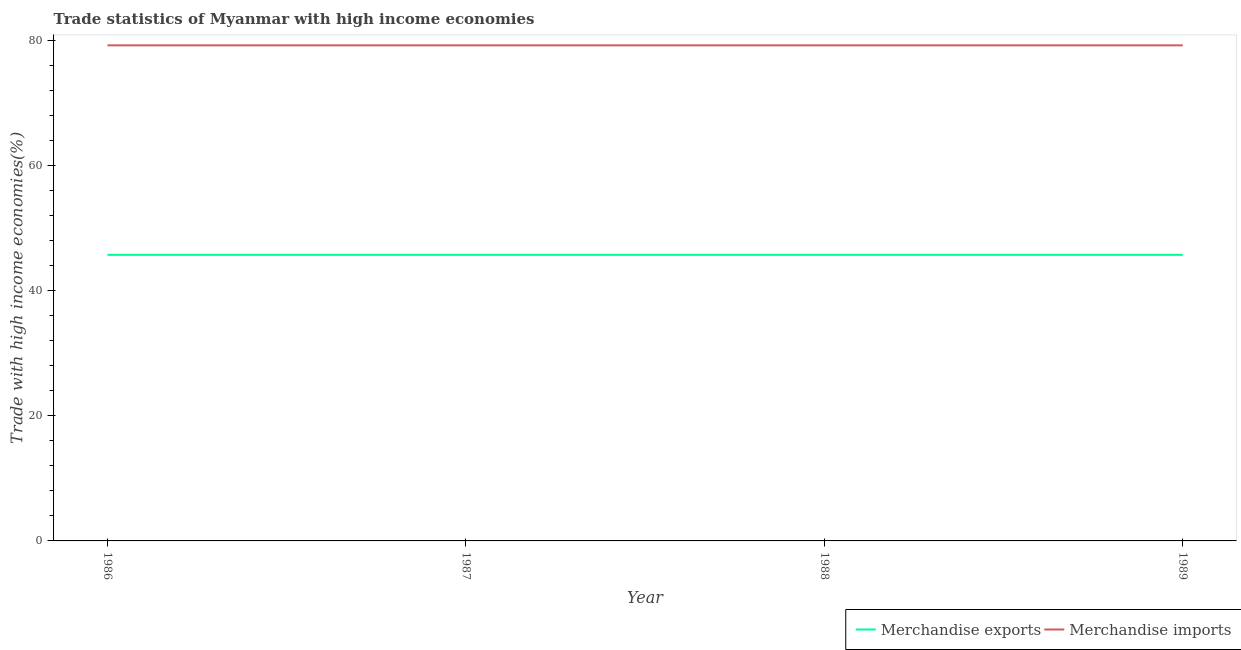What is the merchandise exports in 1987?
Your answer should be compact. 45.78. Across all years, what is the maximum merchandise imports?
Ensure brevity in your answer.  79.29. Across all years, what is the minimum merchandise exports?
Offer a terse response. 45.78. What is the total merchandise exports in the graph?
Offer a terse response. 183.1. What is the difference between the merchandise exports in 1986 and that in 1987?
Provide a succinct answer. -5.2303050779300975e-11. What is the difference between the merchandise exports in 1989 and the merchandise imports in 1988?
Offer a terse response. -33.52. What is the average merchandise exports per year?
Offer a terse response. 45.78. In the year 1986, what is the difference between the merchandise exports and merchandise imports?
Offer a very short reply. -33.52. What is the ratio of the merchandise imports in 1986 to that in 1989?
Your response must be concise. 1. Is the merchandise imports in 1988 less than that in 1989?
Keep it short and to the point. Yes. What is the difference between the highest and the second highest merchandise imports?
Provide a short and direct response. 2.9739055662503233e-10. What is the difference between the highest and the lowest merchandise imports?
Your response must be concise. 1.3973377122056263e-8. Is the sum of the merchandise imports in 1986 and 1989 greater than the maximum merchandise exports across all years?
Offer a very short reply. Yes. How many lines are there?
Your answer should be compact. 2. What is the difference between two consecutive major ticks on the Y-axis?
Your response must be concise. 20. Does the graph contain grids?
Your response must be concise. No. How are the legend labels stacked?
Make the answer very short. Horizontal. What is the title of the graph?
Provide a short and direct response. Trade statistics of Myanmar with high income economies. Does "Mineral" appear as one of the legend labels in the graph?
Make the answer very short. No. What is the label or title of the X-axis?
Offer a very short reply. Year. What is the label or title of the Y-axis?
Offer a very short reply. Trade with high income economies(%). What is the Trade with high income economies(%) of Merchandise exports in 1986?
Your response must be concise. 45.78. What is the Trade with high income economies(%) of Merchandise imports in 1986?
Your answer should be compact. 79.29. What is the Trade with high income economies(%) of Merchandise exports in 1987?
Give a very brief answer. 45.78. What is the Trade with high income economies(%) in Merchandise imports in 1987?
Offer a very short reply. 79.29. What is the Trade with high income economies(%) in Merchandise exports in 1988?
Your answer should be compact. 45.78. What is the Trade with high income economies(%) in Merchandise imports in 1988?
Ensure brevity in your answer.  79.29. What is the Trade with high income economies(%) in Merchandise exports in 1989?
Ensure brevity in your answer.  45.78. What is the Trade with high income economies(%) in Merchandise imports in 1989?
Your answer should be compact. 79.29. Across all years, what is the maximum Trade with high income economies(%) of Merchandise exports?
Provide a short and direct response. 45.78. Across all years, what is the maximum Trade with high income economies(%) in Merchandise imports?
Offer a terse response. 79.29. Across all years, what is the minimum Trade with high income economies(%) of Merchandise exports?
Give a very brief answer. 45.78. Across all years, what is the minimum Trade with high income economies(%) of Merchandise imports?
Your answer should be very brief. 79.29. What is the total Trade with high income economies(%) of Merchandise exports in the graph?
Keep it short and to the point. 183.1. What is the total Trade with high income economies(%) of Merchandise imports in the graph?
Your answer should be compact. 317.16. What is the difference between the Trade with high income economies(%) of Merchandise exports in 1986 and that in 1988?
Provide a short and direct response. -0. What is the difference between the Trade with high income economies(%) in Merchandise imports in 1987 and that in 1988?
Give a very brief answer. 0. What is the difference between the Trade with high income economies(%) of Merchandise exports in 1986 and the Trade with high income economies(%) of Merchandise imports in 1987?
Ensure brevity in your answer.  -33.52. What is the difference between the Trade with high income economies(%) of Merchandise exports in 1986 and the Trade with high income economies(%) of Merchandise imports in 1988?
Your response must be concise. -33.52. What is the difference between the Trade with high income economies(%) of Merchandise exports in 1986 and the Trade with high income economies(%) of Merchandise imports in 1989?
Your answer should be compact. -33.52. What is the difference between the Trade with high income economies(%) of Merchandise exports in 1987 and the Trade with high income economies(%) of Merchandise imports in 1988?
Offer a very short reply. -33.52. What is the difference between the Trade with high income economies(%) in Merchandise exports in 1987 and the Trade with high income economies(%) in Merchandise imports in 1989?
Your answer should be compact. -33.52. What is the difference between the Trade with high income economies(%) in Merchandise exports in 1988 and the Trade with high income economies(%) in Merchandise imports in 1989?
Make the answer very short. -33.52. What is the average Trade with high income economies(%) in Merchandise exports per year?
Make the answer very short. 45.77. What is the average Trade with high income economies(%) of Merchandise imports per year?
Give a very brief answer. 79.29. In the year 1986, what is the difference between the Trade with high income economies(%) in Merchandise exports and Trade with high income economies(%) in Merchandise imports?
Ensure brevity in your answer.  -33.52. In the year 1987, what is the difference between the Trade with high income economies(%) in Merchandise exports and Trade with high income economies(%) in Merchandise imports?
Offer a terse response. -33.52. In the year 1988, what is the difference between the Trade with high income economies(%) in Merchandise exports and Trade with high income economies(%) in Merchandise imports?
Your answer should be very brief. -33.52. In the year 1989, what is the difference between the Trade with high income economies(%) in Merchandise exports and Trade with high income economies(%) in Merchandise imports?
Offer a very short reply. -33.52. What is the ratio of the Trade with high income economies(%) in Merchandise exports in 1986 to that in 1987?
Provide a short and direct response. 1. What is the ratio of the Trade with high income economies(%) in Merchandise imports in 1986 to that in 1987?
Ensure brevity in your answer.  1. What is the ratio of the Trade with high income economies(%) in Merchandise exports in 1986 to that in 1988?
Offer a very short reply. 1. What is the ratio of the Trade with high income economies(%) of Merchandise imports in 1986 to that in 1988?
Give a very brief answer. 1. What is the ratio of the Trade with high income economies(%) of Merchandise imports in 1986 to that in 1989?
Ensure brevity in your answer.  1. What is the ratio of the Trade with high income economies(%) of Merchandise exports in 1988 to that in 1989?
Your response must be concise. 1. What is the ratio of the Trade with high income economies(%) in Merchandise imports in 1988 to that in 1989?
Your answer should be compact. 1. What is the difference between the highest and the second highest Trade with high income economies(%) of Merchandise exports?
Offer a terse response. 0. What is the difference between the highest and the lowest Trade with high income economies(%) in Merchandise exports?
Provide a short and direct response. 0. What is the difference between the highest and the lowest Trade with high income economies(%) in Merchandise imports?
Your answer should be compact. 0. 